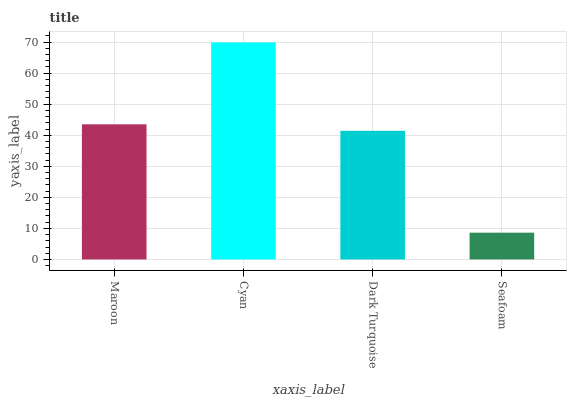Is Seafoam the minimum?
Answer yes or no. Yes. Is Cyan the maximum?
Answer yes or no. Yes. Is Dark Turquoise the minimum?
Answer yes or no. No. Is Dark Turquoise the maximum?
Answer yes or no. No. Is Cyan greater than Dark Turquoise?
Answer yes or no. Yes. Is Dark Turquoise less than Cyan?
Answer yes or no. Yes. Is Dark Turquoise greater than Cyan?
Answer yes or no. No. Is Cyan less than Dark Turquoise?
Answer yes or no. No. Is Maroon the high median?
Answer yes or no. Yes. Is Dark Turquoise the low median?
Answer yes or no. Yes. Is Cyan the high median?
Answer yes or no. No. Is Seafoam the low median?
Answer yes or no. No. 